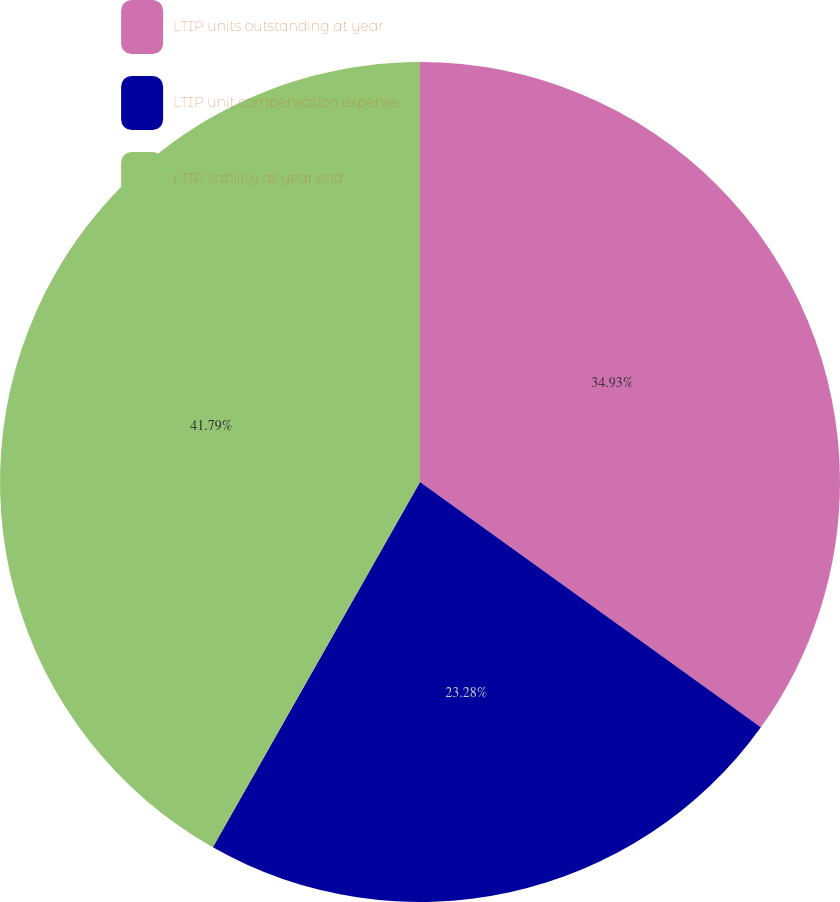<chart> <loc_0><loc_0><loc_500><loc_500><pie_chart><fcel>LTIP units outstanding at year<fcel>LTIP unit compensation expense<fcel>LTIP liability at year end<nl><fcel>34.93%<fcel>23.28%<fcel>41.79%<nl></chart> 